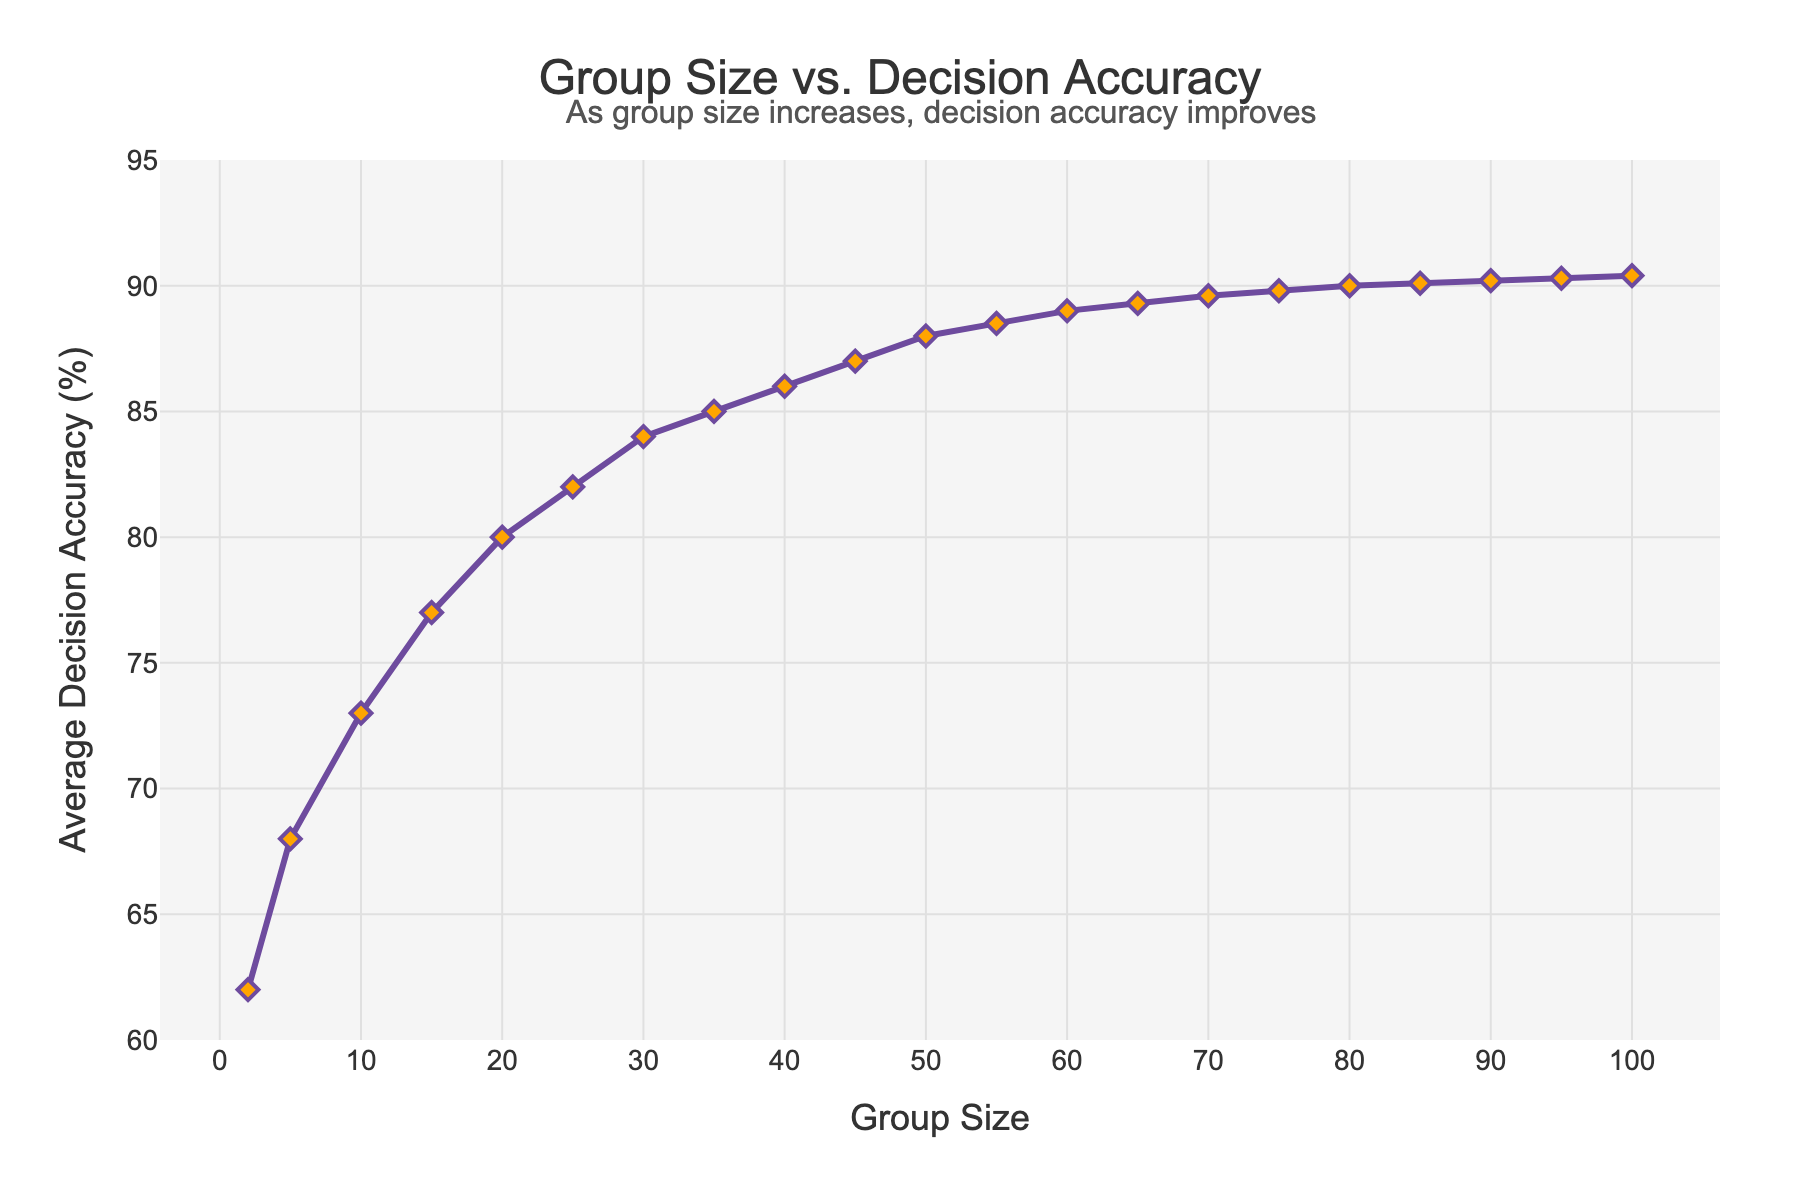What is the average decision accuracy for a group size of 50? Identify the point on the chart where the group size is 50. The corresponding decision accuracy on the vertical axis is 88%.
Answer: 88% How much does the average decision accuracy improve from a group size of 2 to a group size of 20? Find the decision accuracy for group sizes 2 and 20. At group size 2, it is 62%. At group size 20, it is 80%. The difference is 80% - 62% = 18%.
Answer: 18% At what group size does the average decision accuracy first reach 90%? Follow the line graph up to where the decision accuracy becomes 90%. This corresponds to a group size of 80.
Answer: 80 Is the increase in decision accuracy more rapid from a group size of 2 to 20 or from 50 to 100? Compare the slope of the line between two intervals. From 2 to 20, the increase is from 62% to 80% (18%). From 50 to 100, the increase is from 88% to 90.4% (2.4%). The increase is more rapid from 2 to 20.
Answer: From 2 to 20 What is the difference in decision accuracy between group sizes 35 and 55? Locate the decision accuracy values for 35 and 55 on the chart. Accuracy at 35 is 85% and at 55 is 88.5%. The difference is 88.5% - 85% = 3.5%.
Answer: 3.5% When does the increase in decision accuracy start to plateau significantly? Observe the rate of change in the slope of the graph. Significant plateauing is seen around group sizes 85 to 100, where the increase is minimal.
Answer: Around 85-100 Verify if the decision accuracy improvement between group sizes 75 and 85 is as significant as between 25 and 35. From 75 to 85, the accuracy improves from 89.8% to 90.1% (0.3%). From 25 to 35, it goes from 82% to 85% (3%). The improvement is more significant between 25 and 35.
Answer: No How does the trend in decision accuracy change as the group size exceeds 60? After group size 60, the slope of the line graph becomes less steep, signifying smaller incremental improvements in decision accuracy.
Answer: Smaller incremental improvements What is the decision accuracy for the smallest and largest group sizes shown? The smallest group size shown is 2 with an accuracy of 62%, and the largest is 100 with an accuracy of 90.4%.
Answer: 62% and 90.4% Compare the decision accuracy at group sizes of 30 and 70. For group size 30, the accuracy is 84%. For group size 70, it is 89.6%.
Answer: 84% and 89.6% 